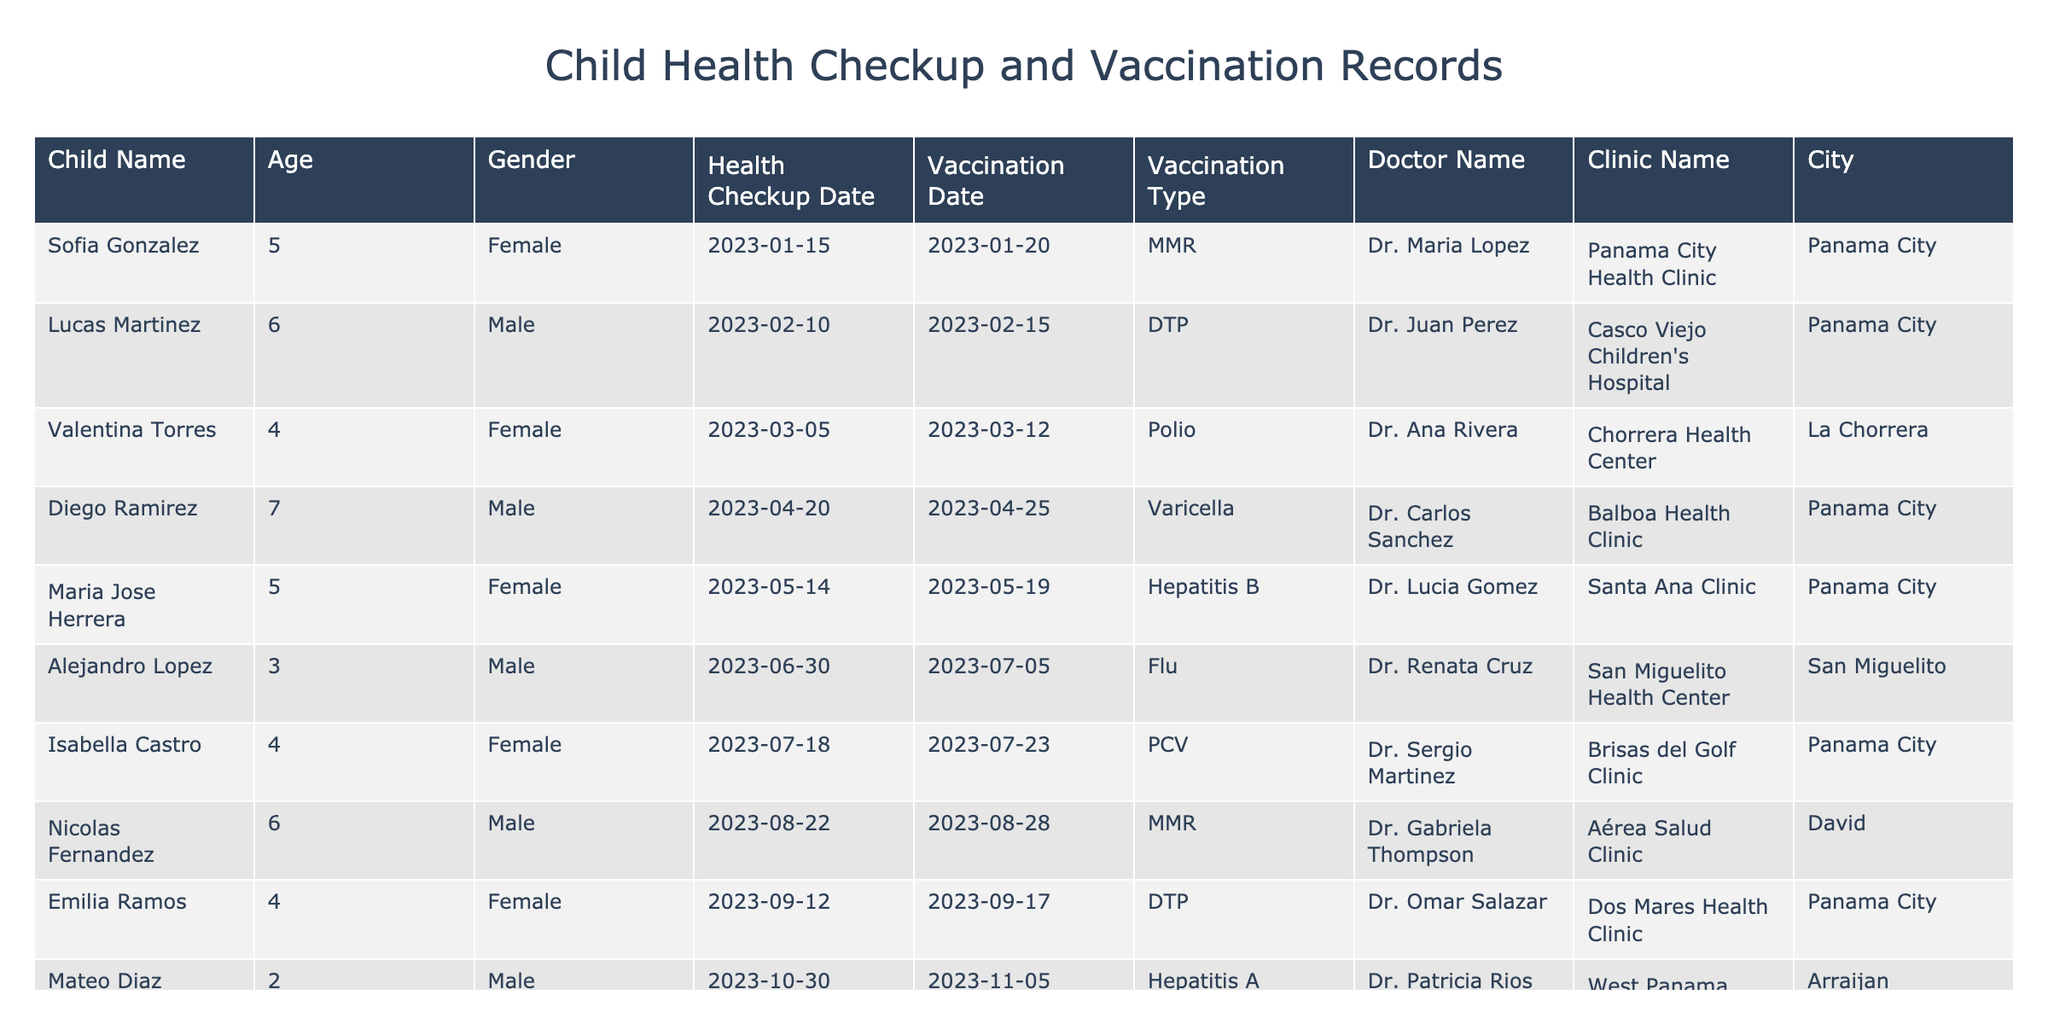What is the vaccination date for Sofia Gonzalez? The table lists a vaccination date for Sofia Gonzalez, which is listed in the "Vaccination Date" column next to her name. The specific date is 2023-01-20.
Answer: 2023-01-20 How many male children had health checkups? By counting the entries in the "Gender" column, there are 5 males listed (Lucas Martinez, Diego Ramirez, Alejandro Lopez, Nicolas Fernandez, Mateo Diaz, and Andres Silva) out of the total 12 entries.
Answer: 5 What type of vaccination did Maria Jose Herrera receive? Maria Jose Herrera’s entry in the "Vaccination Type" column specifies that she received the Hepatitis B vaccination.
Answer: Hepatitis B Which clinic did Diego Ramirez go to for his health checkup? According to the "Clinic Name" column, Diego Ramirez had his health checkup at Balboa Health Clinic.
Answer: Balboa Health Clinic How many vaccinations were given in total in 2023? To find the total number of vaccinations, count the number of unique entries in the "Vaccination Date" column, which lists 12 unique vaccination records.
Answer: 12 Is there any child who received the MMR vaccination in the first quarter of 2023? By examining both the "Vaccination Date" and "Vaccination Type" columns, it shows that Sofia Gonzalez received the MMR vaccination on 2023-01-20 within the first quarter (January-March).
Answer: Yes Which age group had the highest number of health checkups? By analyzing the ages listed, the 5-year-olds (Sofia Gonzalez, Maria Jose Herrera, and Andres Silva) had 3 health checkups, which is the highest compared to other age groups.
Answer: 5 years old How many children received DTP vaccinations? From the "Vaccination Type" column, there are two entries for DTP vaccinations (Lucas Martinez and Emilia Ramos).
Answer: 2 What is the average age of the children who visited the clinics? To find the average age, sum the ages (5 + 6 + 4 + 7 + 5 + 3 + 4 + 6 + 4 + 2 + 3 + 5 = 57) and divide by the number of children (12), resulting in an average age of 57/12 ≈ 4.75.
Answer: 4.75 Did any child receive a vaccination in November? By referencing the "Vaccination Date" column, Gabriela Lopez and Mateo Diaz received vaccinations in November (2023-11-20 and 2023-11-05, respectively), confirming that there were vaccinations in November.
Answer: Yes 